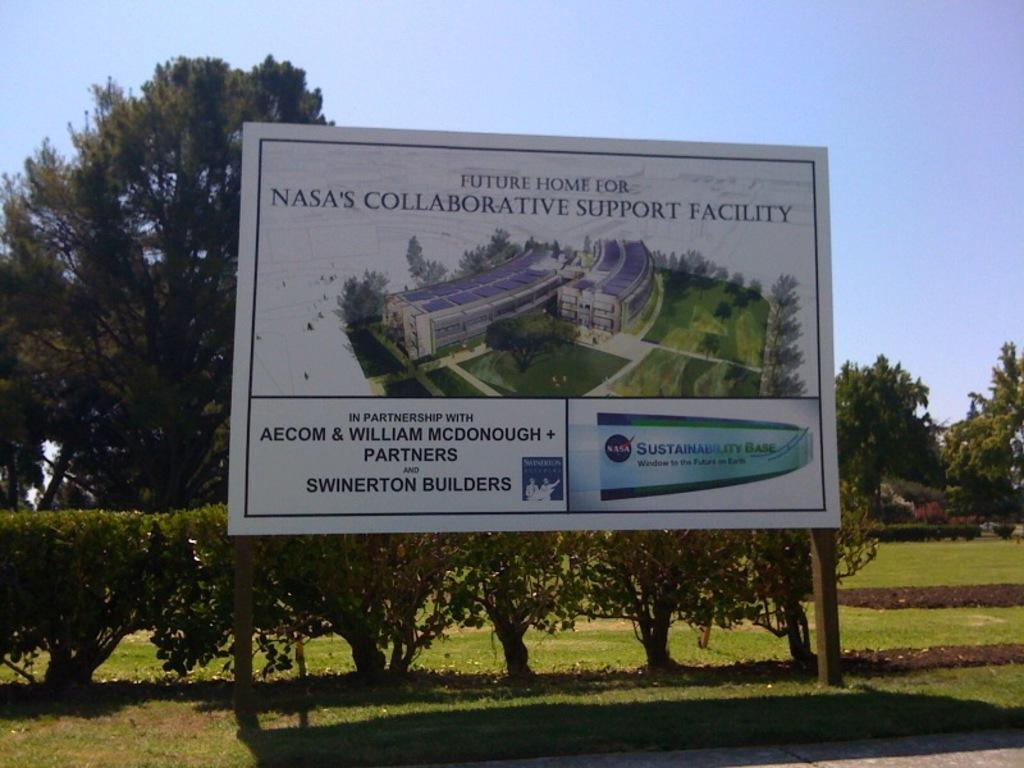<image>
Describe the image concisely. A billboard says that this is the future home for NASA's Collaborative Support Facility. 